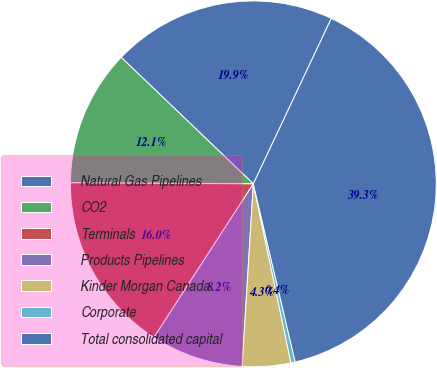Convert chart to OTSL. <chart><loc_0><loc_0><loc_500><loc_500><pie_chart><fcel>Natural Gas Pipelines<fcel>CO2<fcel>Terminals<fcel>Products Pipelines<fcel>Kinder Morgan Canada<fcel>Corporate<fcel>Total consolidated capital<nl><fcel>19.85%<fcel>12.06%<fcel>15.95%<fcel>8.17%<fcel>4.27%<fcel>0.38%<fcel>39.31%<nl></chart> 